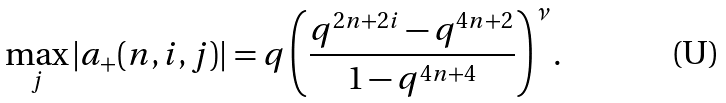Convert formula to latex. <formula><loc_0><loc_0><loc_500><loc_500>\max _ { j } | a _ { + } ( n , i , j ) | = q \left ( \frac { q ^ { 2 n + 2 i } - q ^ { 4 n + 2 } } { 1 - q ^ { 4 n + 4 } } \right ) ^ { \nu } .</formula> 